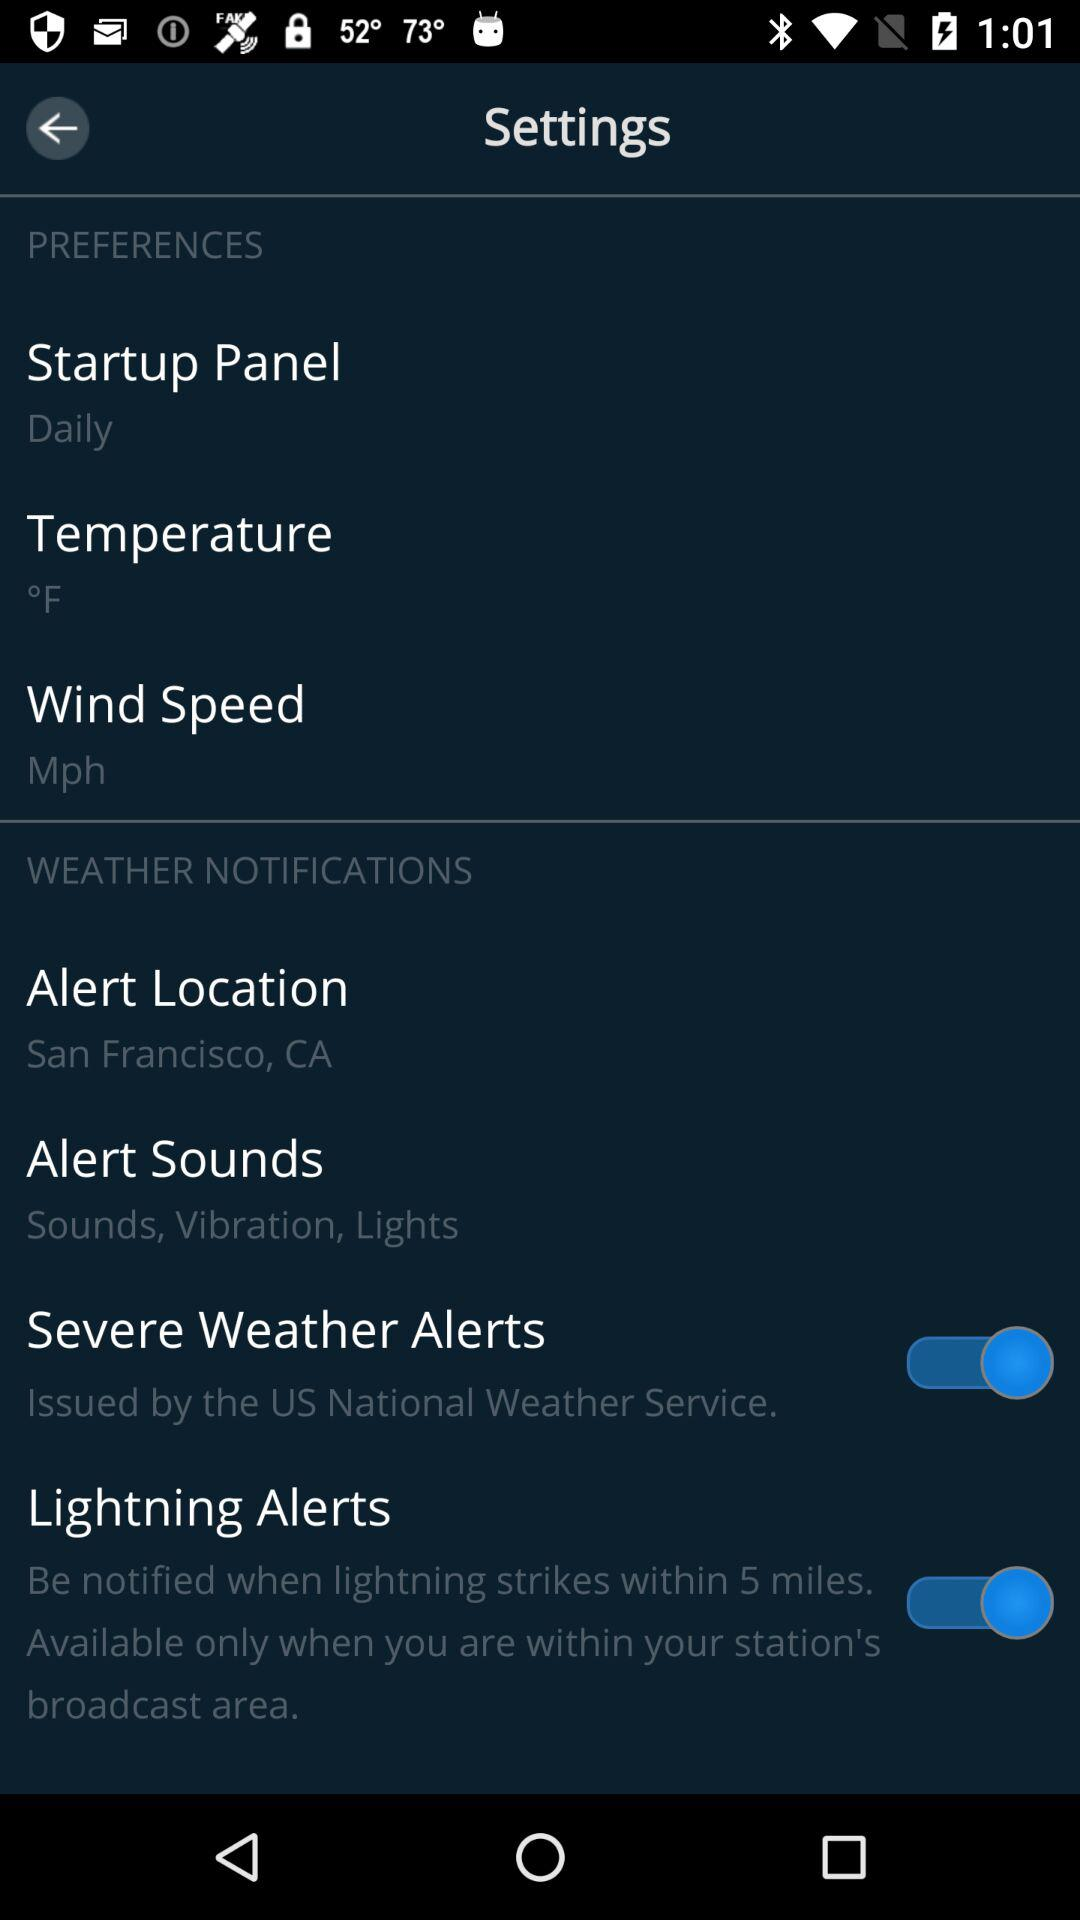What is the current status of the "Lightning Alerts"? The current status is "on". 